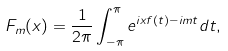<formula> <loc_0><loc_0><loc_500><loc_500>F _ { m } ( x ) = \frac { 1 } { 2 \pi } \int _ { - \pi } ^ { \pi } e ^ { i x f ( t ) - i m t } d t ,</formula> 